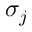Convert formula to latex. <formula><loc_0><loc_0><loc_500><loc_500>\sigma _ { j }</formula> 